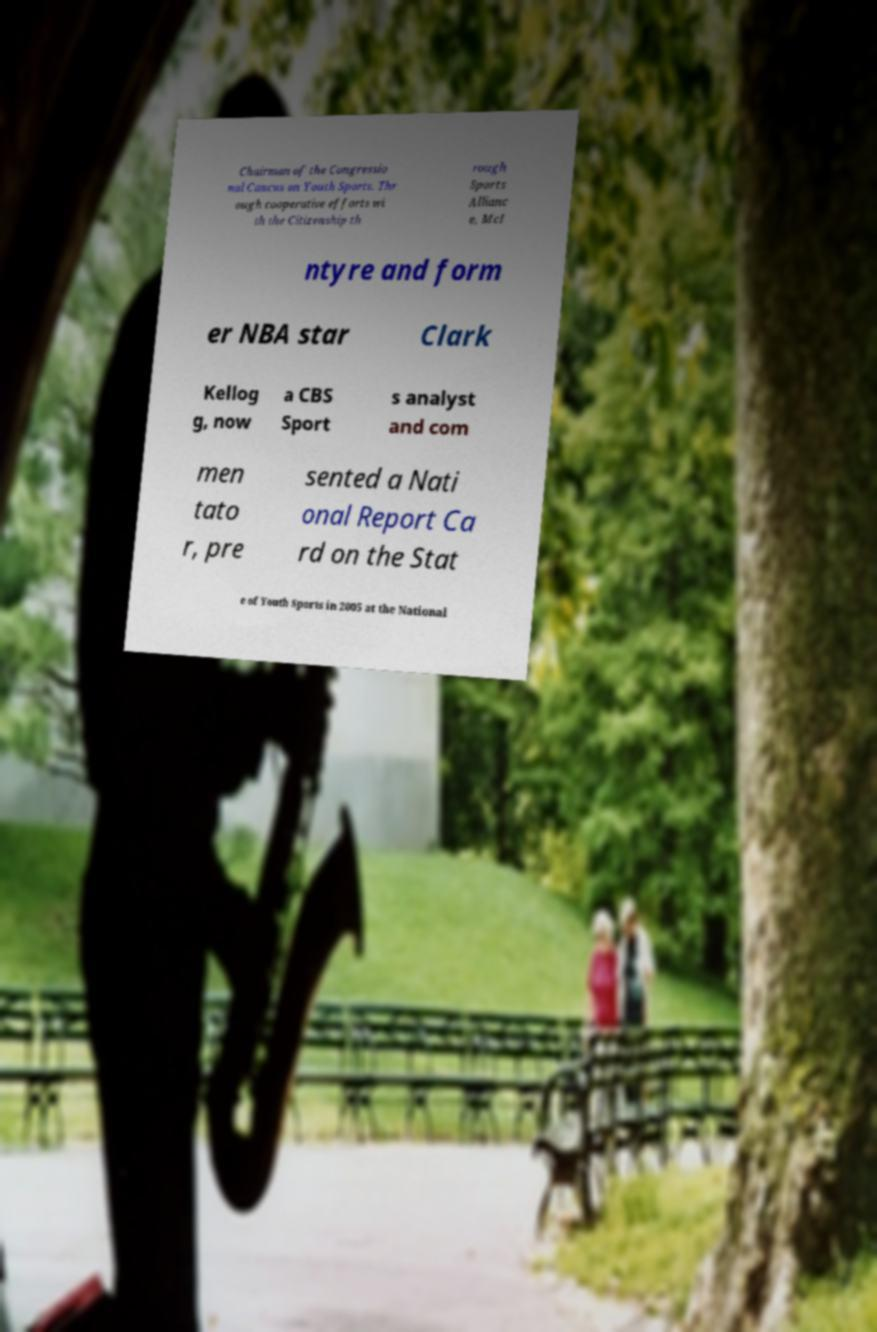Can you accurately transcribe the text from the provided image for me? Chairman of the Congressio nal Caucus on Youth Sports. Thr ough cooperative efforts wi th the Citizenship th rough Sports Allianc e, McI ntyre and form er NBA star Clark Kellog g, now a CBS Sport s analyst and com men tato r, pre sented a Nati onal Report Ca rd on the Stat e of Youth Sports in 2005 at the National 